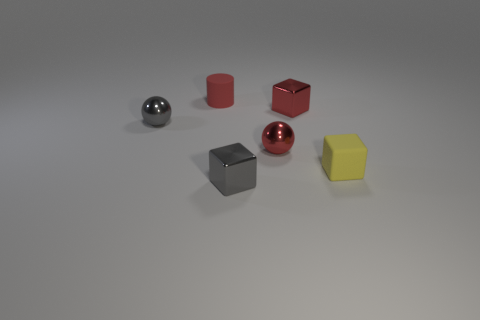Subtract all red balls. How many balls are left? 1 Subtract all small shiny cubes. How many cubes are left? 1 Add 3 large red cylinders. How many objects exist? 9 Add 5 tiny rubber cylinders. How many tiny rubber cylinders are left? 6 Add 5 small gray shiny cylinders. How many small gray shiny cylinders exist? 5 Subtract 0 purple cylinders. How many objects are left? 6 Subtract all cylinders. How many objects are left? 5 Subtract 2 cubes. How many cubes are left? 1 Subtract all cyan cylinders. Subtract all red balls. How many cylinders are left? 1 Subtract all green cylinders. How many purple cubes are left? 0 